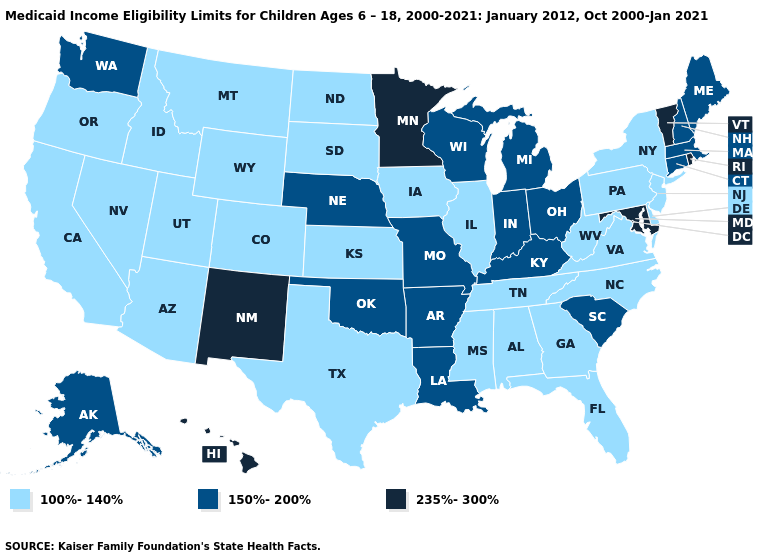What is the lowest value in states that border Iowa?
Keep it brief. 100%-140%. What is the value of Wisconsin?
Write a very short answer. 150%-200%. What is the lowest value in the South?
Write a very short answer. 100%-140%. Name the states that have a value in the range 100%-140%?
Be succinct. Alabama, Arizona, California, Colorado, Delaware, Florida, Georgia, Idaho, Illinois, Iowa, Kansas, Mississippi, Montana, Nevada, New Jersey, New York, North Carolina, North Dakota, Oregon, Pennsylvania, South Dakota, Tennessee, Texas, Utah, Virginia, West Virginia, Wyoming. What is the lowest value in states that border Arizona?
Give a very brief answer. 100%-140%. What is the value of Hawaii?
Short answer required. 235%-300%. Among the states that border New York , which have the highest value?
Write a very short answer. Vermont. Name the states that have a value in the range 150%-200%?
Concise answer only. Alaska, Arkansas, Connecticut, Indiana, Kentucky, Louisiana, Maine, Massachusetts, Michigan, Missouri, Nebraska, New Hampshire, Ohio, Oklahoma, South Carolina, Washington, Wisconsin. What is the highest value in states that border Oklahoma?
Concise answer only. 235%-300%. Does Michigan have the same value as Nebraska?
Write a very short answer. Yes. What is the value of California?
Answer briefly. 100%-140%. Among the states that border North Dakota , does Minnesota have the lowest value?
Answer briefly. No. Name the states that have a value in the range 235%-300%?
Quick response, please. Hawaii, Maryland, Minnesota, New Mexico, Rhode Island, Vermont. Does Oklahoma have a higher value than Louisiana?
Short answer required. No. What is the value of Ohio?
Give a very brief answer. 150%-200%. 